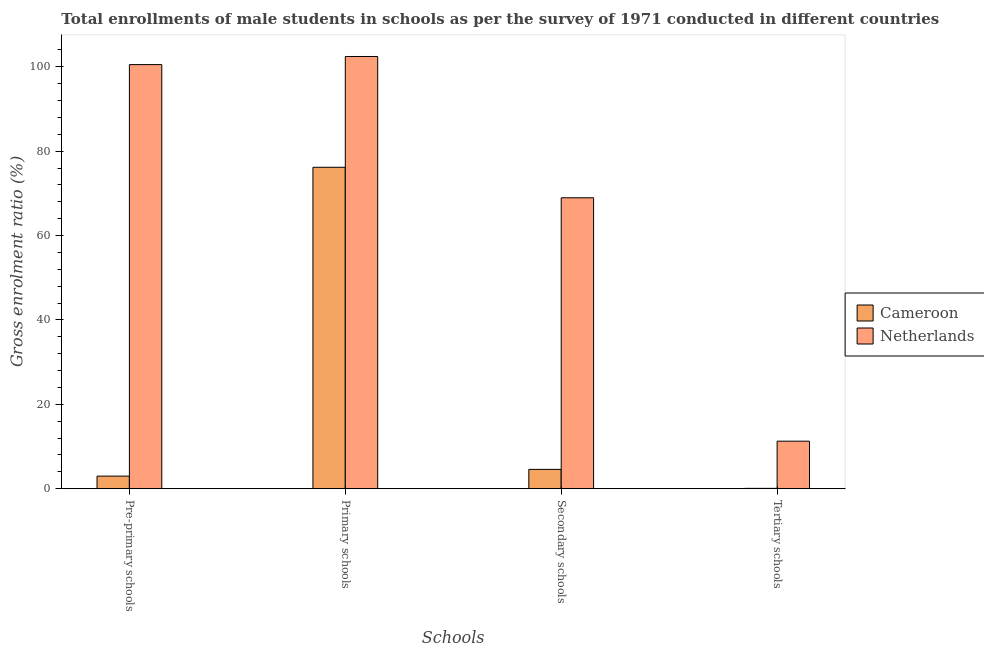How many different coloured bars are there?
Give a very brief answer. 2. What is the label of the 4th group of bars from the left?
Make the answer very short. Tertiary schools. What is the gross enrolment ratio(male) in tertiary schools in Cameroon?
Keep it short and to the point. 0.07. Across all countries, what is the maximum gross enrolment ratio(male) in primary schools?
Offer a very short reply. 102.44. Across all countries, what is the minimum gross enrolment ratio(male) in pre-primary schools?
Offer a very short reply. 2.98. In which country was the gross enrolment ratio(male) in pre-primary schools minimum?
Ensure brevity in your answer.  Cameroon. What is the total gross enrolment ratio(male) in pre-primary schools in the graph?
Provide a short and direct response. 103.5. What is the difference between the gross enrolment ratio(male) in primary schools in Cameroon and that in Netherlands?
Your answer should be very brief. -26.26. What is the difference between the gross enrolment ratio(male) in secondary schools in Cameroon and the gross enrolment ratio(male) in tertiary schools in Netherlands?
Provide a succinct answer. -6.69. What is the average gross enrolment ratio(male) in tertiary schools per country?
Provide a succinct answer. 5.66. What is the difference between the gross enrolment ratio(male) in secondary schools and gross enrolment ratio(male) in primary schools in Netherlands?
Your response must be concise. -33.49. In how many countries, is the gross enrolment ratio(male) in primary schools greater than 68 %?
Your answer should be very brief. 2. What is the ratio of the gross enrolment ratio(male) in pre-primary schools in Netherlands to that in Cameroon?
Your response must be concise. 33.76. Is the difference between the gross enrolment ratio(male) in primary schools in Netherlands and Cameroon greater than the difference between the gross enrolment ratio(male) in secondary schools in Netherlands and Cameroon?
Make the answer very short. No. What is the difference between the highest and the second highest gross enrolment ratio(male) in pre-primary schools?
Offer a terse response. 97.54. What is the difference between the highest and the lowest gross enrolment ratio(male) in secondary schools?
Give a very brief answer. 64.38. In how many countries, is the gross enrolment ratio(male) in tertiary schools greater than the average gross enrolment ratio(male) in tertiary schools taken over all countries?
Ensure brevity in your answer.  1. Is the sum of the gross enrolment ratio(male) in tertiary schools in Cameroon and Netherlands greater than the maximum gross enrolment ratio(male) in pre-primary schools across all countries?
Provide a succinct answer. No. Is it the case that in every country, the sum of the gross enrolment ratio(male) in primary schools and gross enrolment ratio(male) in secondary schools is greater than the sum of gross enrolment ratio(male) in tertiary schools and gross enrolment ratio(male) in pre-primary schools?
Give a very brief answer. Yes. What does the 1st bar from the left in Secondary schools represents?
Ensure brevity in your answer.  Cameroon. What does the 2nd bar from the right in Tertiary schools represents?
Offer a terse response. Cameroon. Is it the case that in every country, the sum of the gross enrolment ratio(male) in pre-primary schools and gross enrolment ratio(male) in primary schools is greater than the gross enrolment ratio(male) in secondary schools?
Your response must be concise. Yes. Are all the bars in the graph horizontal?
Make the answer very short. No. Are the values on the major ticks of Y-axis written in scientific E-notation?
Ensure brevity in your answer.  No. Does the graph contain grids?
Your answer should be compact. No. How many legend labels are there?
Keep it short and to the point. 2. How are the legend labels stacked?
Offer a terse response. Vertical. What is the title of the graph?
Give a very brief answer. Total enrollments of male students in schools as per the survey of 1971 conducted in different countries. What is the label or title of the X-axis?
Offer a terse response. Schools. What is the Gross enrolment ratio (%) in Cameroon in Pre-primary schools?
Keep it short and to the point. 2.98. What is the Gross enrolment ratio (%) in Netherlands in Pre-primary schools?
Ensure brevity in your answer.  100.52. What is the Gross enrolment ratio (%) of Cameroon in Primary schools?
Keep it short and to the point. 76.18. What is the Gross enrolment ratio (%) of Netherlands in Primary schools?
Provide a succinct answer. 102.44. What is the Gross enrolment ratio (%) of Cameroon in Secondary schools?
Your answer should be very brief. 4.57. What is the Gross enrolment ratio (%) in Netherlands in Secondary schools?
Offer a very short reply. 68.95. What is the Gross enrolment ratio (%) in Cameroon in Tertiary schools?
Give a very brief answer. 0.07. What is the Gross enrolment ratio (%) of Netherlands in Tertiary schools?
Provide a short and direct response. 11.26. Across all Schools, what is the maximum Gross enrolment ratio (%) of Cameroon?
Provide a short and direct response. 76.18. Across all Schools, what is the maximum Gross enrolment ratio (%) in Netherlands?
Provide a succinct answer. 102.44. Across all Schools, what is the minimum Gross enrolment ratio (%) in Cameroon?
Provide a short and direct response. 0.07. Across all Schools, what is the minimum Gross enrolment ratio (%) of Netherlands?
Offer a very short reply. 11.26. What is the total Gross enrolment ratio (%) in Cameroon in the graph?
Provide a succinct answer. 83.8. What is the total Gross enrolment ratio (%) in Netherlands in the graph?
Provide a succinct answer. 283.17. What is the difference between the Gross enrolment ratio (%) in Cameroon in Pre-primary schools and that in Primary schools?
Ensure brevity in your answer.  -73.2. What is the difference between the Gross enrolment ratio (%) in Netherlands in Pre-primary schools and that in Primary schools?
Provide a succinct answer. -1.92. What is the difference between the Gross enrolment ratio (%) of Cameroon in Pre-primary schools and that in Secondary schools?
Ensure brevity in your answer.  -1.6. What is the difference between the Gross enrolment ratio (%) in Netherlands in Pre-primary schools and that in Secondary schools?
Your response must be concise. 31.57. What is the difference between the Gross enrolment ratio (%) of Cameroon in Pre-primary schools and that in Tertiary schools?
Your response must be concise. 2.91. What is the difference between the Gross enrolment ratio (%) of Netherlands in Pre-primary schools and that in Tertiary schools?
Your answer should be compact. 89.26. What is the difference between the Gross enrolment ratio (%) of Cameroon in Primary schools and that in Secondary schools?
Ensure brevity in your answer.  71.61. What is the difference between the Gross enrolment ratio (%) of Netherlands in Primary schools and that in Secondary schools?
Keep it short and to the point. 33.49. What is the difference between the Gross enrolment ratio (%) of Cameroon in Primary schools and that in Tertiary schools?
Provide a short and direct response. 76.11. What is the difference between the Gross enrolment ratio (%) of Netherlands in Primary schools and that in Tertiary schools?
Keep it short and to the point. 91.18. What is the difference between the Gross enrolment ratio (%) of Cameroon in Secondary schools and that in Tertiary schools?
Offer a very short reply. 4.5. What is the difference between the Gross enrolment ratio (%) of Netherlands in Secondary schools and that in Tertiary schools?
Your answer should be compact. 57.69. What is the difference between the Gross enrolment ratio (%) of Cameroon in Pre-primary schools and the Gross enrolment ratio (%) of Netherlands in Primary schools?
Your response must be concise. -99.47. What is the difference between the Gross enrolment ratio (%) in Cameroon in Pre-primary schools and the Gross enrolment ratio (%) in Netherlands in Secondary schools?
Provide a succinct answer. -65.97. What is the difference between the Gross enrolment ratio (%) of Cameroon in Pre-primary schools and the Gross enrolment ratio (%) of Netherlands in Tertiary schools?
Keep it short and to the point. -8.28. What is the difference between the Gross enrolment ratio (%) of Cameroon in Primary schools and the Gross enrolment ratio (%) of Netherlands in Secondary schools?
Make the answer very short. 7.23. What is the difference between the Gross enrolment ratio (%) in Cameroon in Primary schools and the Gross enrolment ratio (%) in Netherlands in Tertiary schools?
Offer a terse response. 64.92. What is the difference between the Gross enrolment ratio (%) of Cameroon in Secondary schools and the Gross enrolment ratio (%) of Netherlands in Tertiary schools?
Ensure brevity in your answer.  -6.69. What is the average Gross enrolment ratio (%) in Cameroon per Schools?
Provide a short and direct response. 20.95. What is the average Gross enrolment ratio (%) of Netherlands per Schools?
Give a very brief answer. 70.79. What is the difference between the Gross enrolment ratio (%) of Cameroon and Gross enrolment ratio (%) of Netherlands in Pre-primary schools?
Give a very brief answer. -97.54. What is the difference between the Gross enrolment ratio (%) of Cameroon and Gross enrolment ratio (%) of Netherlands in Primary schools?
Your response must be concise. -26.26. What is the difference between the Gross enrolment ratio (%) in Cameroon and Gross enrolment ratio (%) in Netherlands in Secondary schools?
Offer a very short reply. -64.38. What is the difference between the Gross enrolment ratio (%) of Cameroon and Gross enrolment ratio (%) of Netherlands in Tertiary schools?
Your response must be concise. -11.19. What is the ratio of the Gross enrolment ratio (%) of Cameroon in Pre-primary schools to that in Primary schools?
Give a very brief answer. 0.04. What is the ratio of the Gross enrolment ratio (%) in Netherlands in Pre-primary schools to that in Primary schools?
Provide a succinct answer. 0.98. What is the ratio of the Gross enrolment ratio (%) of Cameroon in Pre-primary schools to that in Secondary schools?
Offer a terse response. 0.65. What is the ratio of the Gross enrolment ratio (%) of Netherlands in Pre-primary schools to that in Secondary schools?
Offer a very short reply. 1.46. What is the ratio of the Gross enrolment ratio (%) in Cameroon in Pre-primary schools to that in Tertiary schools?
Keep it short and to the point. 41.52. What is the ratio of the Gross enrolment ratio (%) in Netherlands in Pre-primary schools to that in Tertiary schools?
Provide a short and direct response. 8.93. What is the ratio of the Gross enrolment ratio (%) of Cameroon in Primary schools to that in Secondary schools?
Your answer should be very brief. 16.66. What is the ratio of the Gross enrolment ratio (%) in Netherlands in Primary schools to that in Secondary schools?
Ensure brevity in your answer.  1.49. What is the ratio of the Gross enrolment ratio (%) in Cameroon in Primary schools to that in Tertiary schools?
Make the answer very short. 1062.48. What is the ratio of the Gross enrolment ratio (%) of Netherlands in Primary schools to that in Tertiary schools?
Give a very brief answer. 9.1. What is the ratio of the Gross enrolment ratio (%) of Cameroon in Secondary schools to that in Tertiary schools?
Provide a short and direct response. 63.77. What is the ratio of the Gross enrolment ratio (%) of Netherlands in Secondary schools to that in Tertiary schools?
Your response must be concise. 6.12. What is the difference between the highest and the second highest Gross enrolment ratio (%) in Cameroon?
Keep it short and to the point. 71.61. What is the difference between the highest and the second highest Gross enrolment ratio (%) of Netherlands?
Your answer should be very brief. 1.92. What is the difference between the highest and the lowest Gross enrolment ratio (%) in Cameroon?
Offer a very short reply. 76.11. What is the difference between the highest and the lowest Gross enrolment ratio (%) in Netherlands?
Make the answer very short. 91.18. 